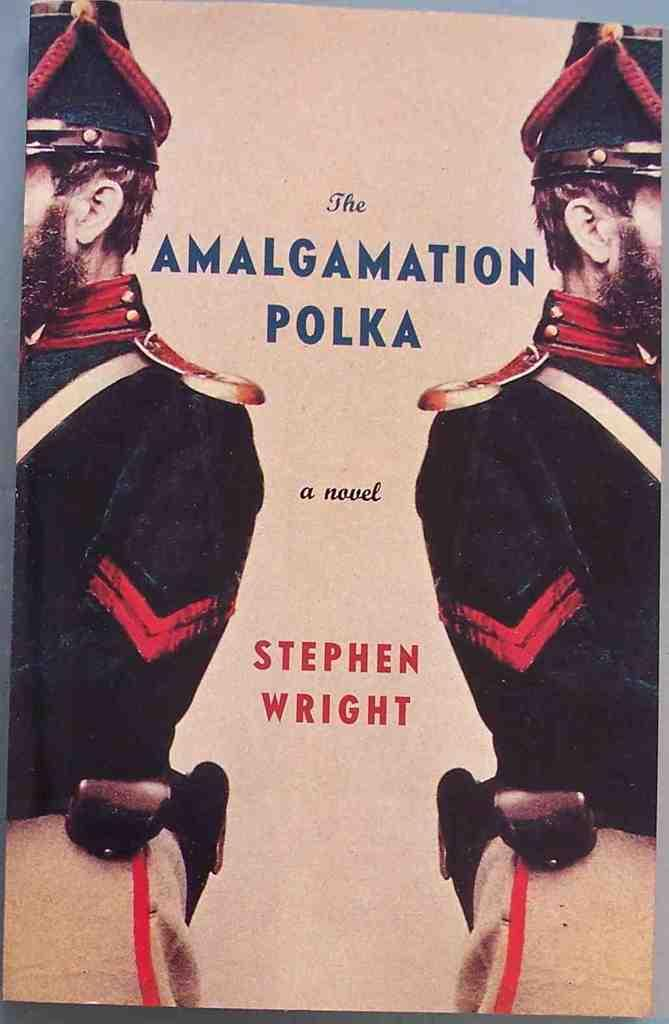What is featured in the image? There is a poster in the image. What can be seen on the poster? There are two people depicted on the poster, and there is text present on the poster. Can you see a snake wrapped around the people on the poster? There is no snake present on the poster; it only features two people and text. 